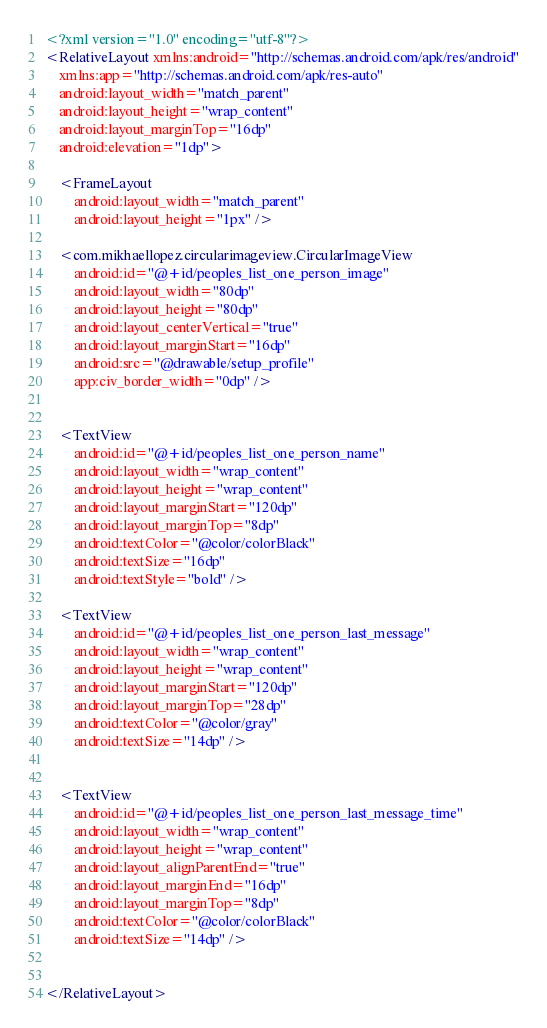Convert code to text. <code><loc_0><loc_0><loc_500><loc_500><_XML_><?xml version="1.0" encoding="utf-8"?>
<RelativeLayout xmlns:android="http://schemas.android.com/apk/res/android"
    xmlns:app="http://schemas.android.com/apk/res-auto"
    android:layout_width="match_parent"
    android:layout_height="wrap_content"
    android:layout_marginTop="16dp"
    android:elevation="1dp">

    <FrameLayout
        android:layout_width="match_parent"
        android:layout_height="1px" />

    <com.mikhaellopez.circularimageview.CircularImageView
        android:id="@+id/peoples_list_one_person_image"
        android:layout_width="80dp"
        android:layout_height="80dp"
        android:layout_centerVertical="true"
        android:layout_marginStart="16dp"
        android:src="@drawable/setup_profile"
        app:civ_border_width="0dp" />


    <TextView
        android:id="@+id/peoples_list_one_person_name"
        android:layout_width="wrap_content"
        android:layout_height="wrap_content"
        android:layout_marginStart="120dp"
        android:layout_marginTop="8dp"
        android:textColor="@color/colorBlack"
        android:textSize="16dp"
        android:textStyle="bold" />

    <TextView
        android:id="@+id/peoples_list_one_person_last_message"
        android:layout_width="wrap_content"
        android:layout_height="wrap_content"
        android:layout_marginStart="120dp"
        android:layout_marginTop="28dp"
        android:textColor="@color/gray"
        android:textSize="14dp" />


    <TextView
        android:id="@+id/peoples_list_one_person_last_message_time"
        android:layout_width="wrap_content"
        android:layout_height="wrap_content"
        android:layout_alignParentEnd="true"
        android:layout_marginEnd="16dp"
        android:layout_marginTop="8dp"
        android:textColor="@color/colorBlack"
        android:textSize="14dp" />
    

</RelativeLayout></code> 